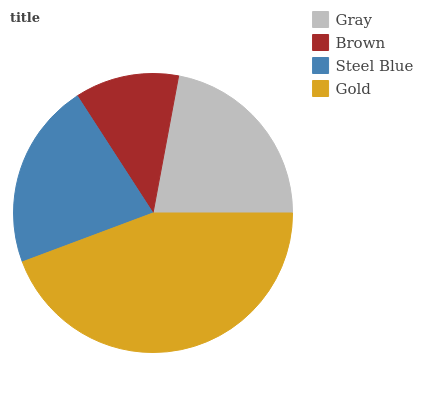Is Brown the minimum?
Answer yes or no. Yes. Is Gold the maximum?
Answer yes or no. Yes. Is Steel Blue the minimum?
Answer yes or no. No. Is Steel Blue the maximum?
Answer yes or no. No. Is Steel Blue greater than Brown?
Answer yes or no. Yes. Is Brown less than Steel Blue?
Answer yes or no. Yes. Is Brown greater than Steel Blue?
Answer yes or no. No. Is Steel Blue less than Brown?
Answer yes or no. No. Is Gray the high median?
Answer yes or no. Yes. Is Steel Blue the low median?
Answer yes or no. Yes. Is Gold the high median?
Answer yes or no. No. Is Brown the low median?
Answer yes or no. No. 